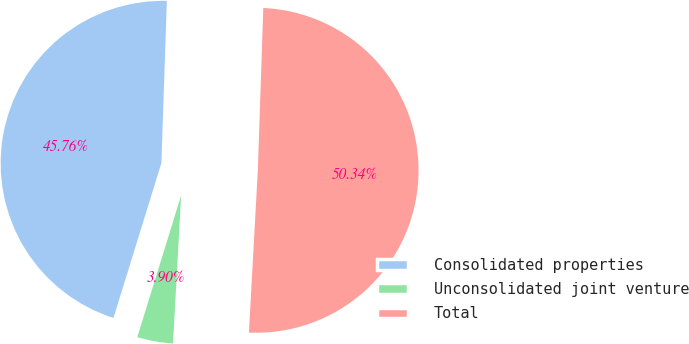Convert chart to OTSL. <chart><loc_0><loc_0><loc_500><loc_500><pie_chart><fcel>Consolidated properties<fcel>Unconsolidated joint venture<fcel>Total<nl><fcel>45.76%<fcel>3.9%<fcel>50.34%<nl></chart> 